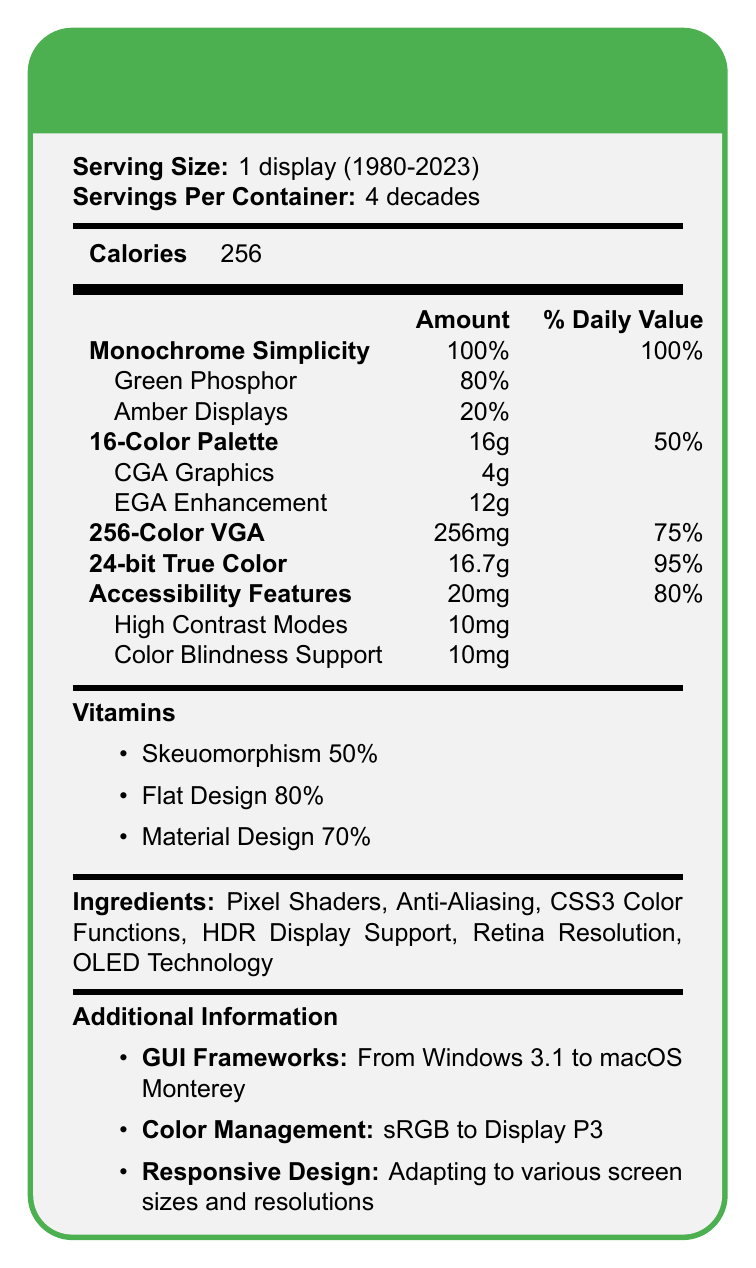What is the serving size mentioned in the document? The serving size is clearly stated in the document as "1 display (1980-2023)".
Answer: 1 display (1980-2023) How many decades does the serving per container cover? The document specifies "4 decades" as the servings per container.
Answer: 4 decades What is the percentage of Green Phosphor under Monochrome Simplicity? The document lists Green Phosphor as having an 80% amount under Monochrome Simplicity.
Answer: 80% How much EGA Enhancement is in the 16-Color Palette? EGA Enhancement is specified as 12g within the 16-Color Palette category in the document.
Answer: 12g What color schemes are included under Monochrome Simplicity? Under Monochrome Simplicity, the two subItems listed are Green Phosphor and Amber Displays.
Answer: Green Phosphor and Amber Displays Which nutrient category contains 256mg in amount? A. 16-Color Palette B. 256-Color VGA C. 24-bit True Color 256-Color VGA is listed with 256mg.
Answer: B Which has the highest daily value among the nutrients listed? A. Monochrome Simplicity B. 256-Color VGA C. 24-bit True Color Monochrome Simplicity is listed with a 100% daily value.
Answer: A What serving size is covered by the document? A. 1 year B. 2 decades C. 1 display (1980-2023) D. 256 displays (1800-2023) The document mentions that the serving size is "1 display (1980-2023)".
Answer: C Is there any information about pie chart usage in the document? The document does not mention anything about pie charts, either in text or visually.
Answer: No Describe the main idea presented in the document. The summary accurately captures the main elements and purpose of the document.
Answer: The document illustrates the evolution of GUI color schemes in nutrition labels from early computer displays to modern high-resolution screens, covering a period from 1980 to 2023. Different categories of color technologies and design philosophies are shown, including Monochrome Simplicity, 16-Color Palette, 256-Color VGA, and 24-bit True Color. It also highlights current-day accessibility features and various vitamins like Skeuomorphism, Flat Design, and Material Design, as well as ingredient technologies like Pixel Shaders and OLED Technology. Lastly, the document provides additional information on GUI frameworks, color management, and responsive design. What are the ingredients listed in the document? The ingredients are explicitly listed in the document.
Answer: Pixel Shaders, Anti-Aliasing, CSS3 Color Functions, HDR Display Support, Retina Resolution, OLED Technology How much Monochrome Simplicity is provided as a daily value? The document states that Monochrome Simplicity has a 100% daily value.
Answer: 100% What percentage of Flat Design is mentioned under vitamins? Flat Design is listed with an 80% amount under the vitamins section.
Answer: 80% What technology is used for accessibility features? The document lists High Contrast Modes and Color Blindness Support under accessibility features.
Answer: High Contrast Modes and Color Blindness Support Based on the document, when did the GUI color scheme evolution start being tracked? The document mentions that the serving size is "1 display (1980-2023)", indicating the evolution started being tracked from 1980.
Answer: 1980 Which interface design philosophy is mentioned with the highest percentage in vitamins? A. Skeuomorphism B. Material Design C. Flat Design Flat Design is listed with 80%, making it the highest among the options in the vitamins section.
Answer: C What does the document list under additional information regarding color management? The additional information section under color management mentions "sRGB to Display P3".
Answer: sRGB to Display P3 What is HGH Display Support listed under? HDR Display Support is found in the ingredients section of the document.
Answer: Ingredients What is the calorie count mentioned in the document? The document lists 256 calories prominently.
Answer: 256 What is the relationship between "16-Color Palette" and "CGA Graphics"? Within the 16-Color Palette, CGA Graphics is one of the subItems listed, indicating its relationship.
Answer: CGA Graphics is a sub-item of the 16-Color Palette Is there enough information to determine the impact of OLED Technology on GUI color schemes? The document lists OLED Technology under ingredients, but does not provide detailed information about its impact on GUI color schemes.
Answer: Not enough information 